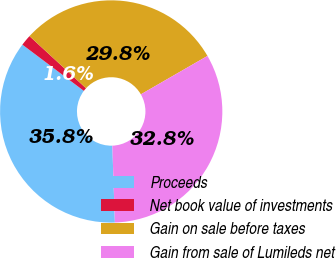<chart> <loc_0><loc_0><loc_500><loc_500><pie_chart><fcel>Proceeds<fcel>Net book value of investments<fcel>Gain on sale before taxes<fcel>Gain from sale of Lumileds net<nl><fcel>35.79%<fcel>1.59%<fcel>29.82%<fcel>32.8%<nl></chart> 